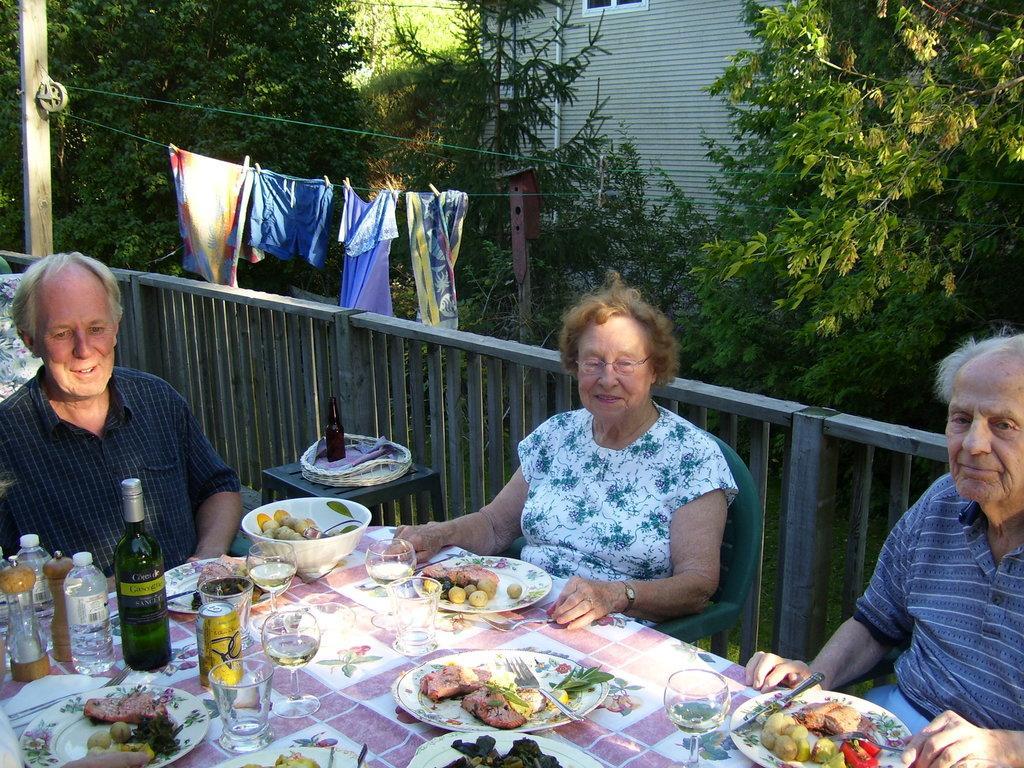In one or two sentences, can you explain what this image depicts? As we can see in the image there is a building, trees, cloths and three people sitting on chairs and there is a table. On table there are plates, food items, glasses, bottles and a cloth. 